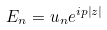<formula> <loc_0><loc_0><loc_500><loc_500>E _ { n } = u _ { n } e ^ { i p \left | z \right | }</formula> 